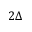Convert formula to latex. <formula><loc_0><loc_0><loc_500><loc_500>2 \Delta</formula> 